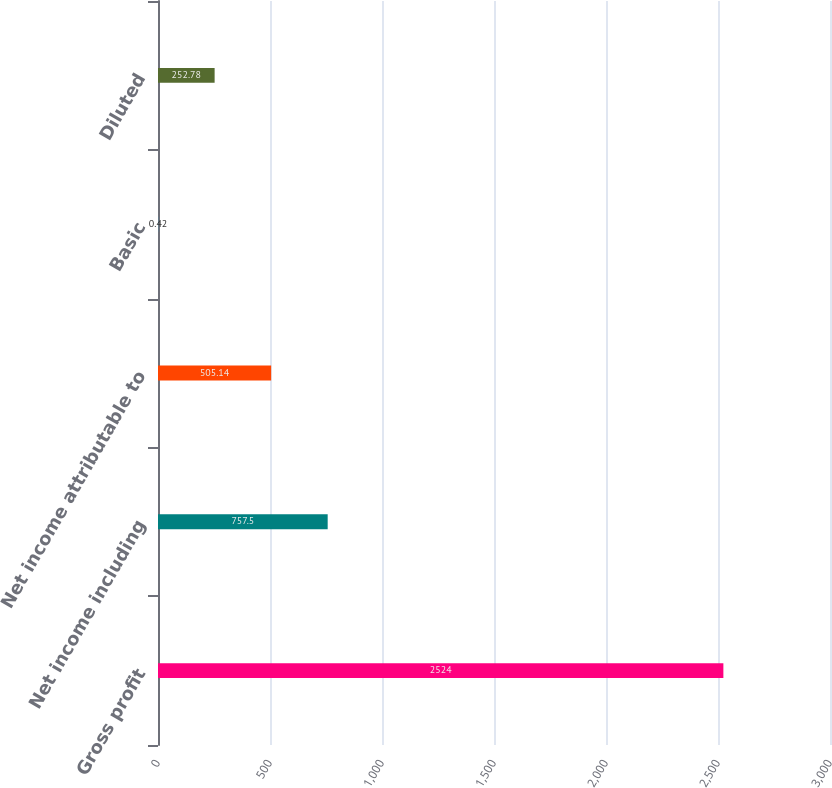Convert chart. <chart><loc_0><loc_0><loc_500><loc_500><bar_chart><fcel>Gross profit<fcel>Net income including<fcel>Net income attributable to<fcel>Basic<fcel>Diluted<nl><fcel>2524<fcel>757.5<fcel>505.14<fcel>0.42<fcel>252.78<nl></chart> 